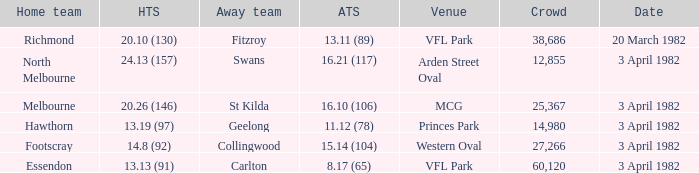When the away team scored 16.21 (117), what was the home teams score? 24.13 (157). 